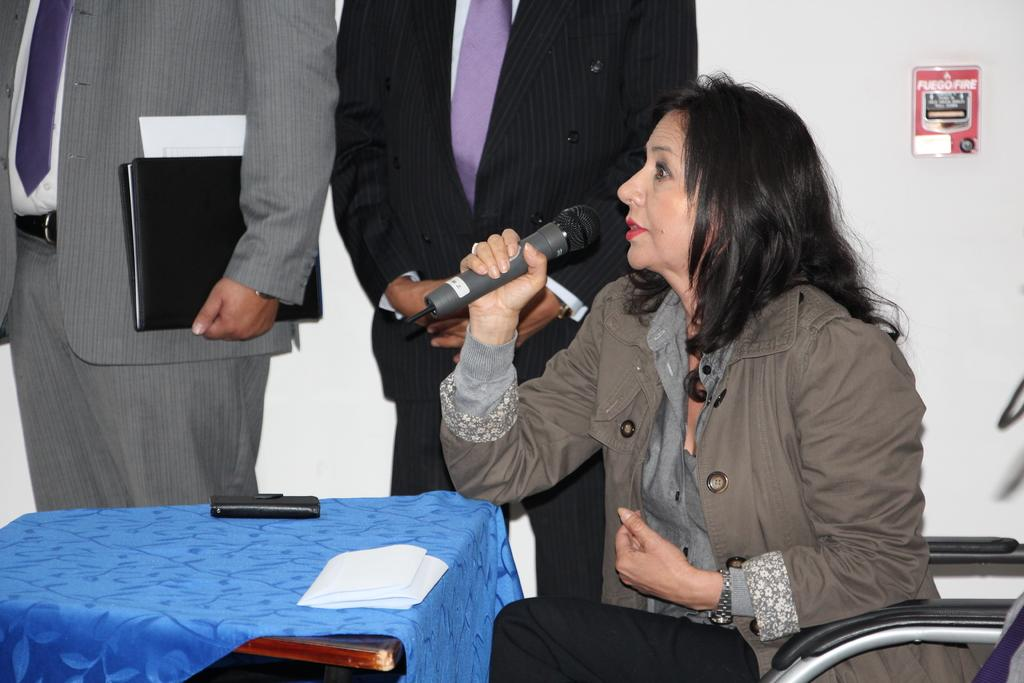What is the main subject of the image? The main subject of the image is a group of people. Can you describe the woman in the image? The woman is sitting on a chair and holding a microphone in the image. What is on the table in the image? There is a table with a blue cloth on it in the image. What type of ink is being used by the woman to write on the apparel in the image? There is no indication in the image that the woman is writing on any apparel, nor is there any ink present. What type of seed is visible on the table in the image? There are no seeds visible on the table in the image. 